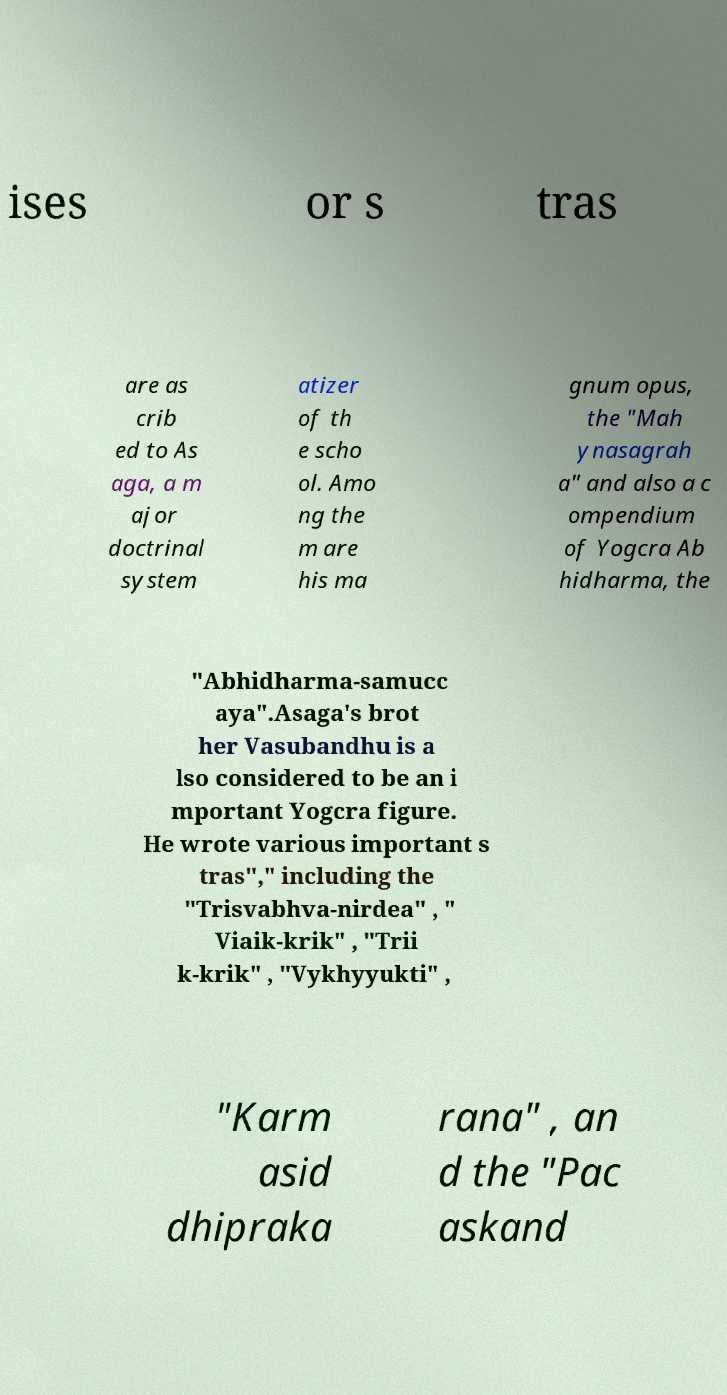Can you accurately transcribe the text from the provided image for me? ises or s tras are as crib ed to As aga, a m ajor doctrinal system atizer of th e scho ol. Amo ng the m are his ma gnum opus, the "Mah ynasagrah a" and also a c ompendium of Yogcra Ab hidharma, the "Abhidharma-samucc aya".Asaga's brot her Vasubandhu is a lso considered to be an i mportant Yogcra figure. He wrote various important s tras"," including the "Trisvabhva-nirdea" , " Viaik-krik" , "Trii k-krik" , "Vykhyyukti" , "Karm asid dhipraka rana" , an d the "Pac askand 